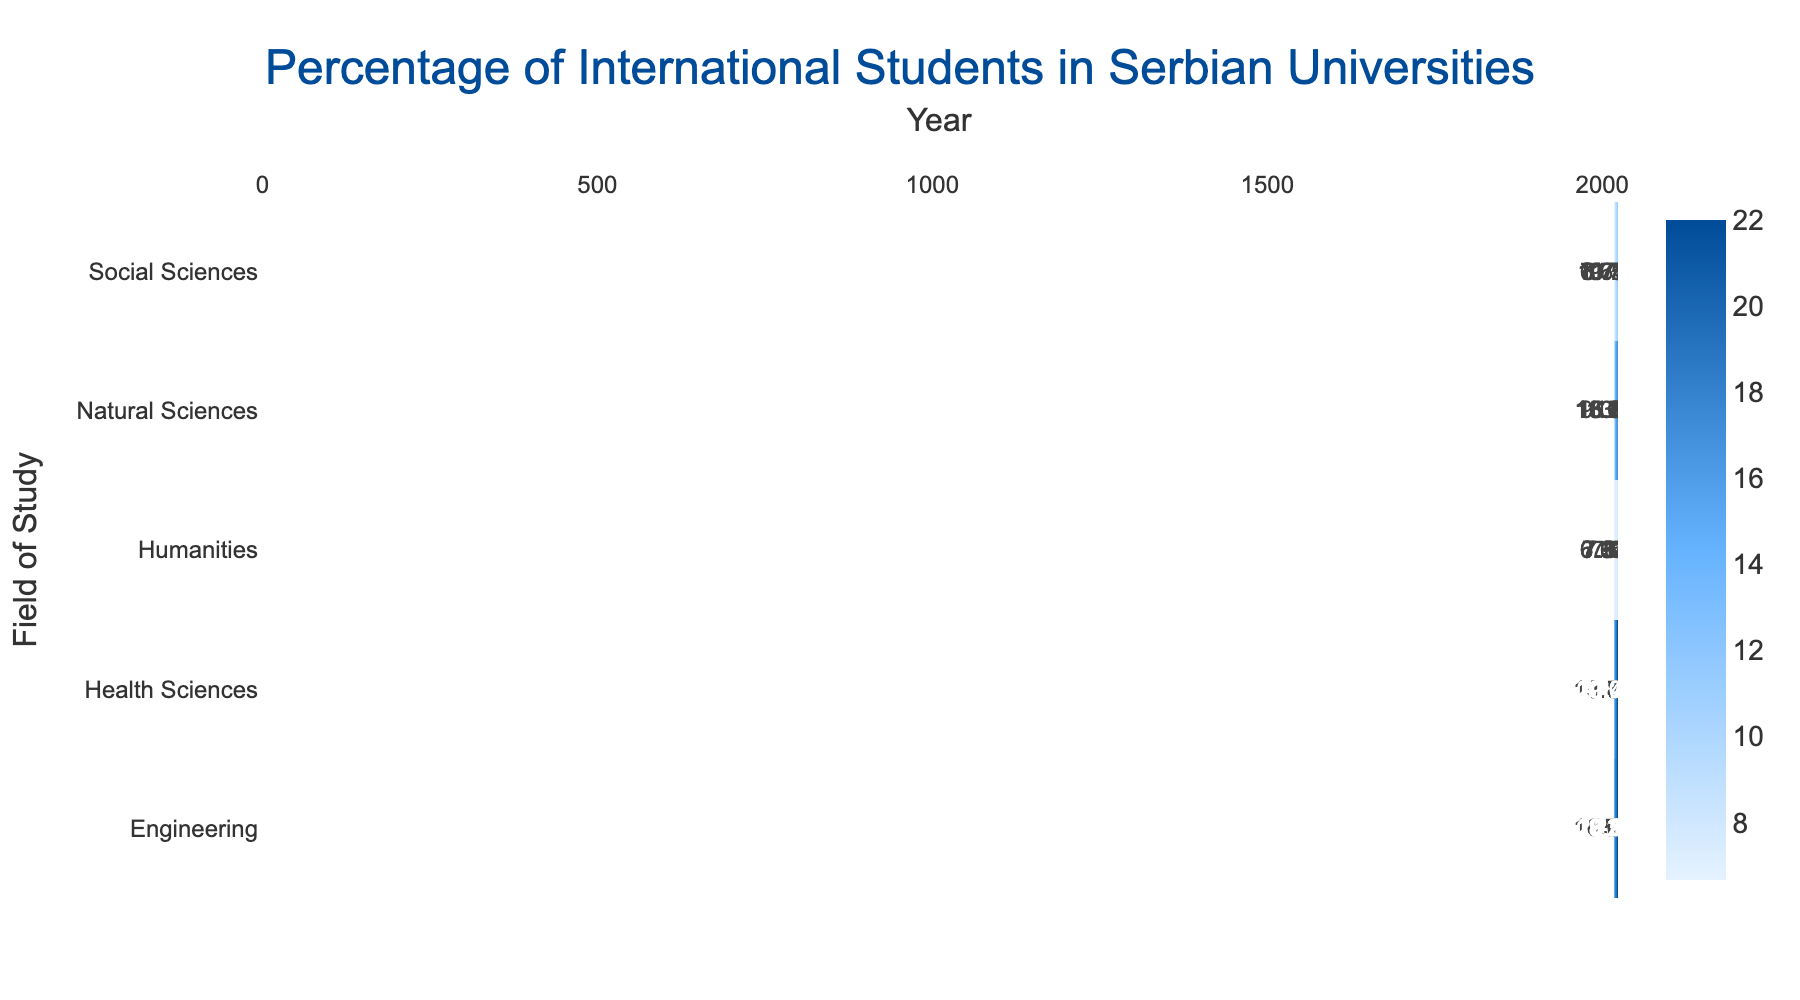What was the percentage of international students in Engineering in 2020? In 2020, the table shows that the percentage of international students in Engineering is 18.18%.
Answer: 18.18% Which field of study had the highest percentage of international students in 2023? By comparing the percentages for each field of study in 2023, Health Sciences has the highest percentage at 21.74%.
Answer: Health Sciences What is the average percentage of international students in Humanities over the years 2018 to 2023? The percentages for Humanities are: 6.67% (2018), 6.92% (2019), 7.14% (2020), 7.33% (2021), 7.50% (2022), and 7.65% (2023). Adding these gives 43.21%, and dividing by 6 years yields an average of 7.20%.
Answer: 7.20% Did the percentage of international students in Social Sciences increase from 2018 to 2023? Comparing the values, Social Sciences had 6.67% in 2018 and 11.11% in 2023. Since 11.11% is greater than 6.67%, the percentage increased.
Answer: Yes What was the difference in the percentage of international students in Natural Sciences between 2018 and 2023? The percentage in 2018 was 9.38%, and in 2023 it was 16.67%. The difference is calculated as 16.67% - 9.38% = 7.29%.
Answer: 7.29% In which year did Health Sciences see the largest percentage increase of international students compared to the previous year? The percentages for Health Sciences are: 13.89% (2018), 15.79% (2019), 17.5% (2020), 19.05% (2021), 20.45% (2022), and 21.74% (2023). The largest increase is from 2021 to 2022 (19.05% to 20.45%), which is an increase of 1.40%.
Answer: 2021 to 2022 Which field of study consistently had the lowest percentage of international students from 2018 to 2023? Examining the data for all fields over the years, Humanities had the lowest percentages each year, starting from 6.67% in 2018 to 7.65% in 2023, remaining below other fields.
Answer: Humanities What is the total percentage of international students across all fields of study in 2022? The percentages in 2022 for each field are: Engineering 20.83%, Social Sciences 10.59%, Health Sciences 20.45%, Humanities 7.50%, and Natural Sciences 16.00%. Adding these gives 85.37% as the total percentage of international students across all fields.
Answer: 85.37% Is there a field of study that had a percentage of international students below 10% in any year? Examining the data, Social Sciences had a percentage below 10% in 2018 (6.67%), confirming that this field does indeed have percentages below 10%.
Answer: Yes Which field of study experienced the greatest growth in the percentage of international students from 2018 to 2023? By analyzing the percentage changes, Engineering started at 15% in 2018 and rose to 22% in 2023, showing the greatest increase of 7%. Comparatively, Health Sciences increased by 7.85% during the same period.
Answer: Engineering 